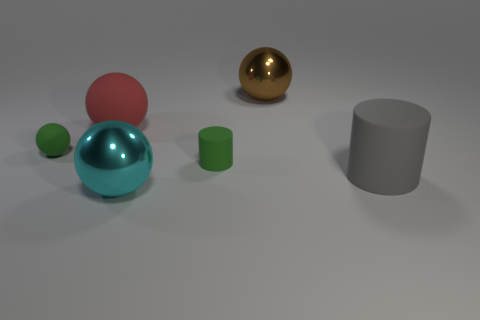Are there any brown shiny objects that have the same size as the red sphere? Yes, there is a brown shiny object to the right of the red sphere that appears to have a similar size. 